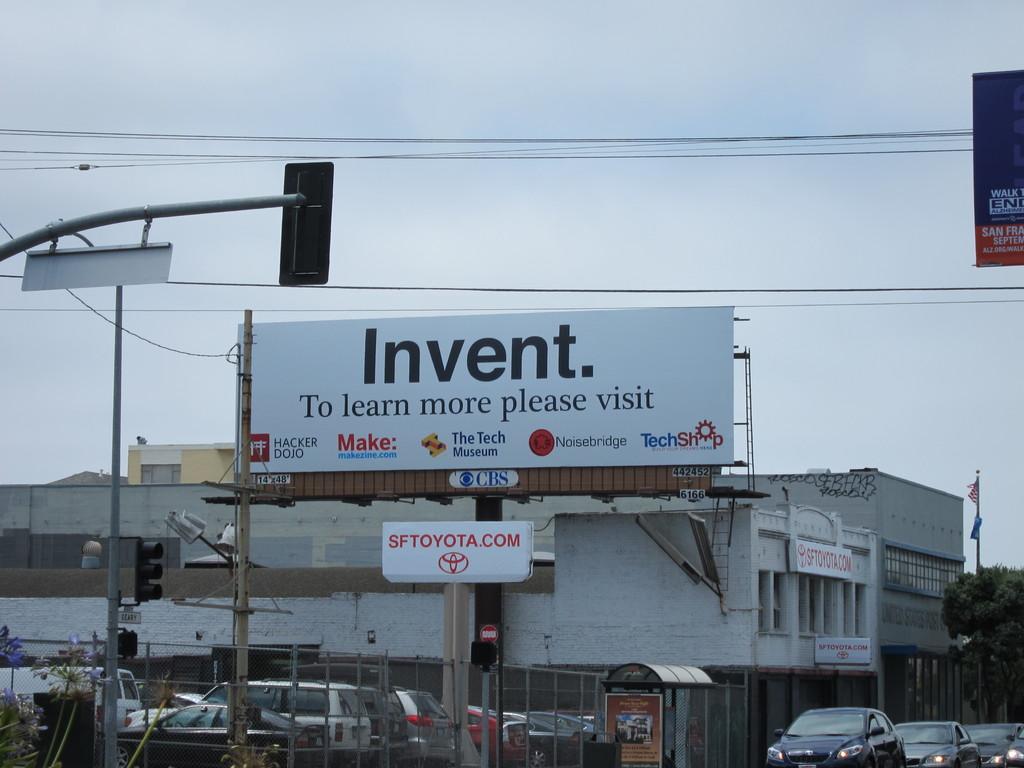The billboard is advertising for?
Offer a very short reply. Invent. 